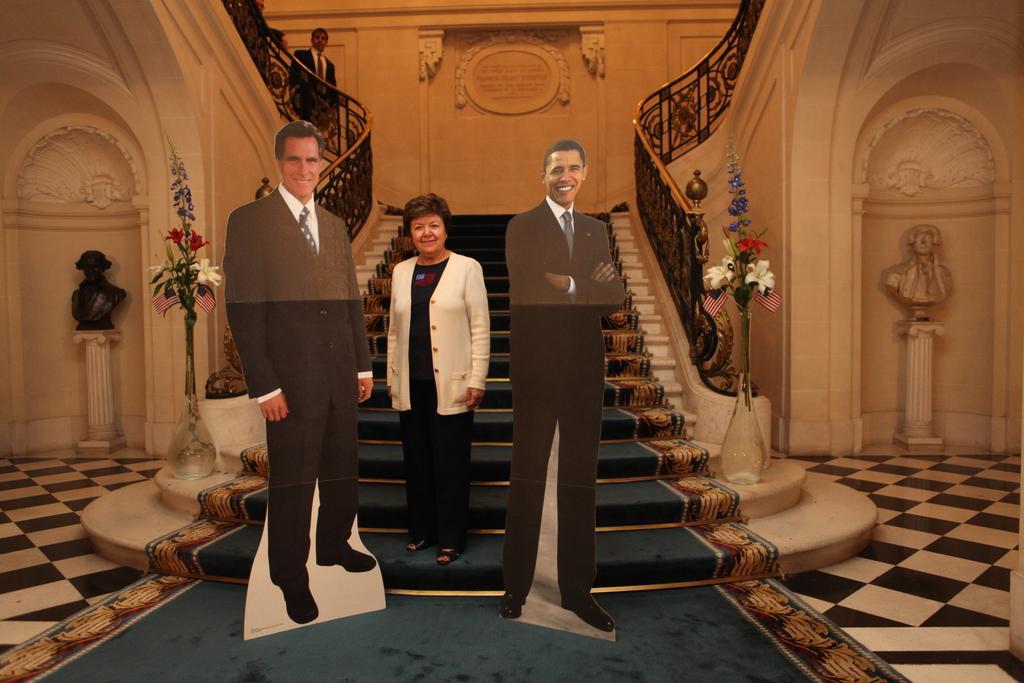Can you describe this image briefly? In this image in the middle I can see a woman standing on steps between poster of two persons in the middle , on steps I can see flower pot and flower and sculptures visible in front of the wall on the right side, on the left side, in front of fence there is a person visible at the top. 